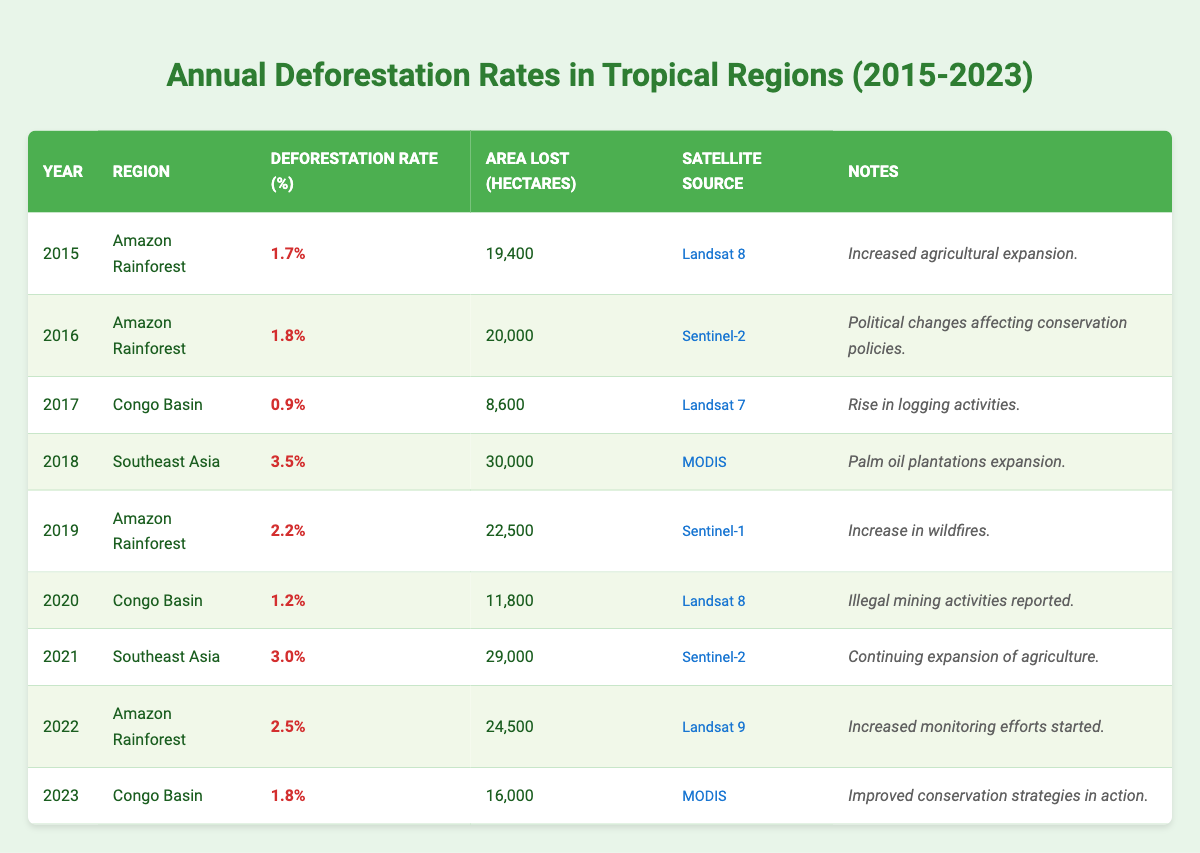What was the deforestation rate in the Amazon Rainforest in 2019? In the table, the deforestation rate for the Amazon Rainforest in 2019 is listed as 2.2%.
Answer: 2.2% Which region had the highest deforestation rate in 2018? The table shows that Southeast Asia had the highest deforestation rate in 2018 at 3.5%.
Answer: Southeast Asia What is the total area lost in hectares from deforestation in the Amazon Rainforest from 2015 to 2022? By summing the area lost in hectares for the Amazon Rainforest from 2015 (19,400), 2016 (20,000), 2019 (22,500), and 2022 (24,500), we get a total of 86,400 hectares.
Answer: 86,400 hectares Was there an increase or decrease in the deforestation rate in the Congo Basin from 2017 to 2023? In 2017 the rate was 0.9%, and in 2023 it was 1.8%. Hence, there was an increase in the deforestation rate in the Congo Basin from 2017 to 2023.
Answer: Increase What was the average deforestation rate in Southeast Asia from 2018 to 2021? The deforestation rates for Southeast Asia are 3.5% (2018), 3.0% (2021). To find the average, we sum the rates (3.5 + 3.0) and divide by 2; average = 6.5/2 = 3.25%.
Answer: 3.25% Which satellite source was used for most of the monitoring in the Amazon Rainforest? The table indicates that Landsat 8, Sentinel-2, Lansat 9, and Sentinel-1 were used, with Landsat 8 appearing twice between 2015 and 2020.
Answer: Landsat 8 How many hectares were lost in the Congo Basin over the years 2017 and 2020 combined? The area lost in the Congo Basin for those years is 8,600 hectares (2017) + 11,800 hectares (2020) = 20,400 hectares total lost.
Answer: 20,400 hectares Was the deforestation rate in the Amazon Rainforest higher in 2022 than in 2015? The deforestation rate in 2022 was 2.5%, while in 2015 it was 1.7%. Therefore, 2022 had a higher deforestation rate than 2015.
Answer: Yes What was the trend in deforestation rates in Southeast Asia from 2018 to 2021? The deforestation rates in Southeast Asia were 3.5% in 2018, decreasing in 2019 to 3.0%, which means it remained relatively high until 2021. Overall, it showed a concerning stability rather than a decline.
Answer: Stabilized high rates Which region maintained a consistent rate of about 1.2% in the years it was documented? The Congo Basin had a deforestation rate of 1.2% in 2020 and the index was low overall in nearby years, representing a consistency around this percentage.
Answer: Congo Basin 